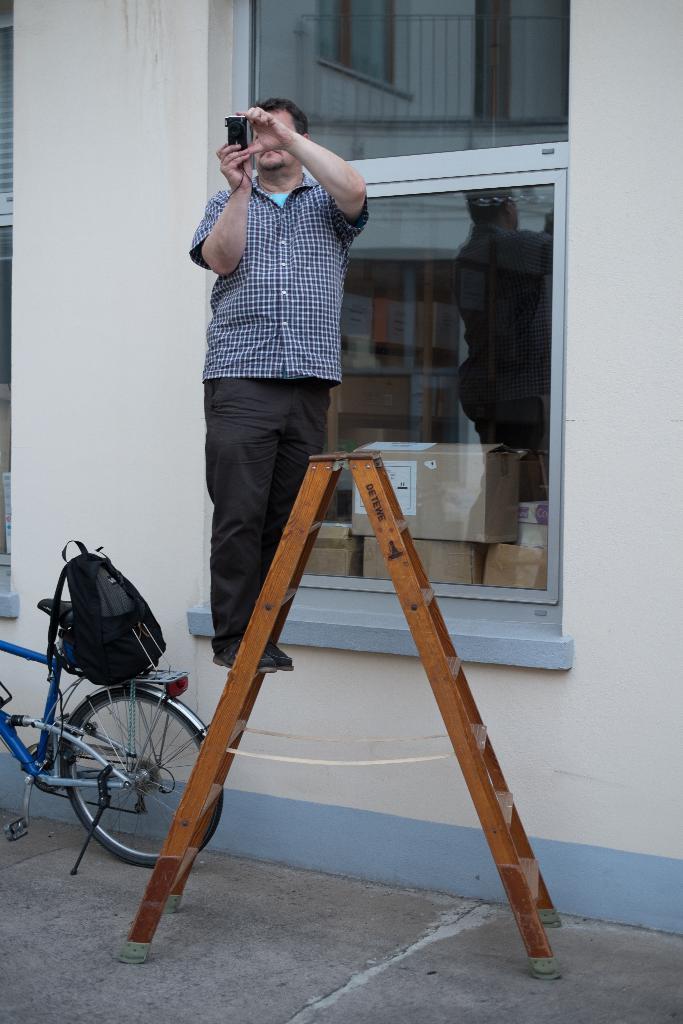In one or two sentences, can you explain what this image depicts? In the middle of the picture, we see a ladder stand. We see a man is standing on the ladder. He is clicking photos with the camera. Behind him, we see a white wall and the glass windows from which we can see the carton boxes. On the left side, we see a bicycle and a bag in black color. At the bottom, we see the road. 